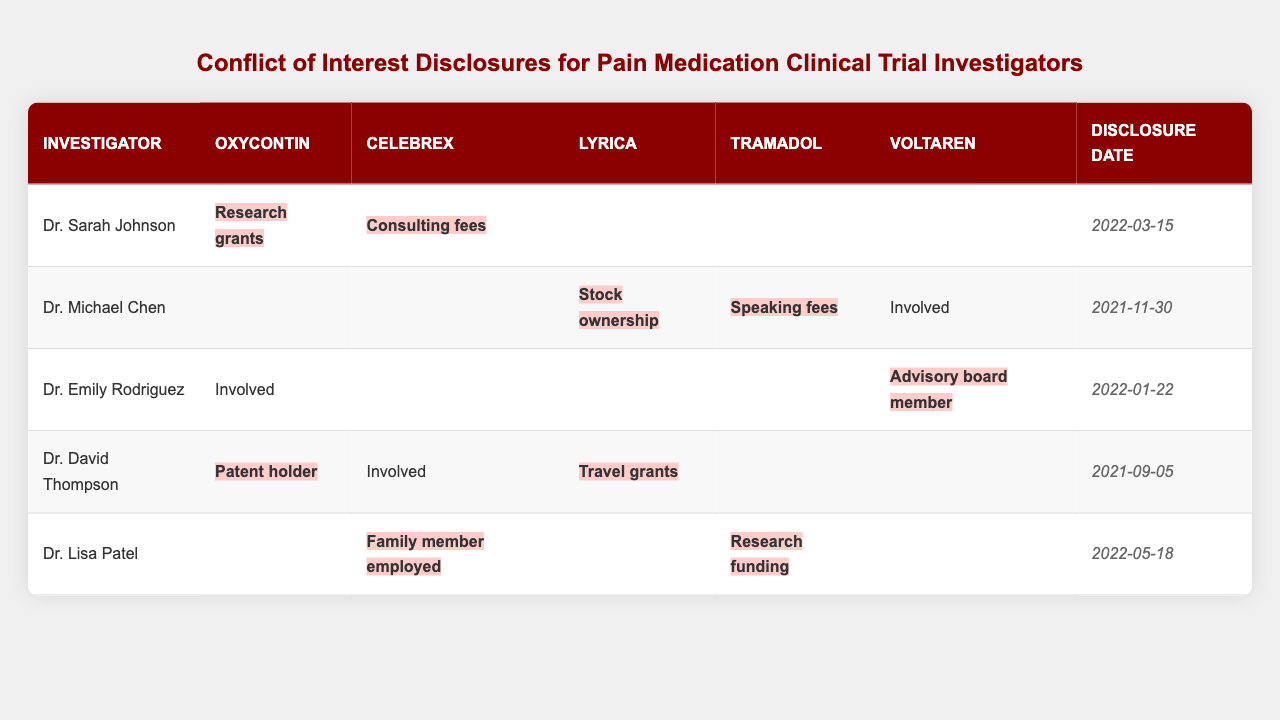What conflict does Dr. Sarah Johnson have with Oxycontin? The table shows that Dr. Sarah Johnson has a conflict related to Oxycontin due to "Research grants."
Answer: Research grants Which painkiller has the most conflicts across all researchers? By reviewing the table, we find that Oxycontin has conflicts for three different investigators: Dr. Sarah Johnson, Dr. David Thompson, and Dr. Emily Rodriguez. Other painkillers have fewer unique conflicts.
Answer: Oxycontin Did Dr. Lisa Patel disclose any conflicts for Voltaren? According to the table, Dr. Lisa Patel has no listed conflicts for Voltaren, indicating a "no" response.
Answer: No How many painkillers does Dr. Michael Chen have conflicts for? Dr. Michael Chen has conflicts for two painkillers: Lyrica and Tramadol. Count these from the table to find the answer.
Answer: Two What is the disclosure date for Dr. David Thompson? The table specifies that Dr. David Thompson's disclosure date is "2021-09-05."
Answer: 2021-09-05 Are all investigators involved in trials for Celebrex? The table indicates that not all investigators are involved in trials for Celebrex (only Dr. Sarah Johnson and Dr. David Thompson). Therefore, the answer is "no."
Answer: No Which doctor has the latest disclosure date? By comparing the disclosure dates in the table, we see that Dr. Lisa Patel's disclosure date is "2022-05-18," which is the latest among all investigators.
Answer: Dr. Lisa Patel Can you count the total number of unique conflicts across all painkillers listed? The unique conflicts are: Research grants, Consulting fees, Stock ownership, Speaking fees, Advisory board member, Patent holder, Travel grants, Family member employed, and Research funding. Counting these gives a total of nine unique conflicts.
Answer: Nine Which researcher has conflicts for both Tramadol and Oxycontin? The table shows that Dr. Sarah Johnson has conflicts with Oxycontin, while Dr. Lisa Patel has conflicts with Tramadol. No single researcher has conflicts for both, leading to the answer being “none.”
Answer: None What percentage of investigators are involved in trials for Voltaren? There are five investigators, and only Dr. Michael Chen and Dr. Emily Rodriguez are involved with Voltaren, which gives a percentage of (2/5)*100 = 40%.
Answer: 40% 